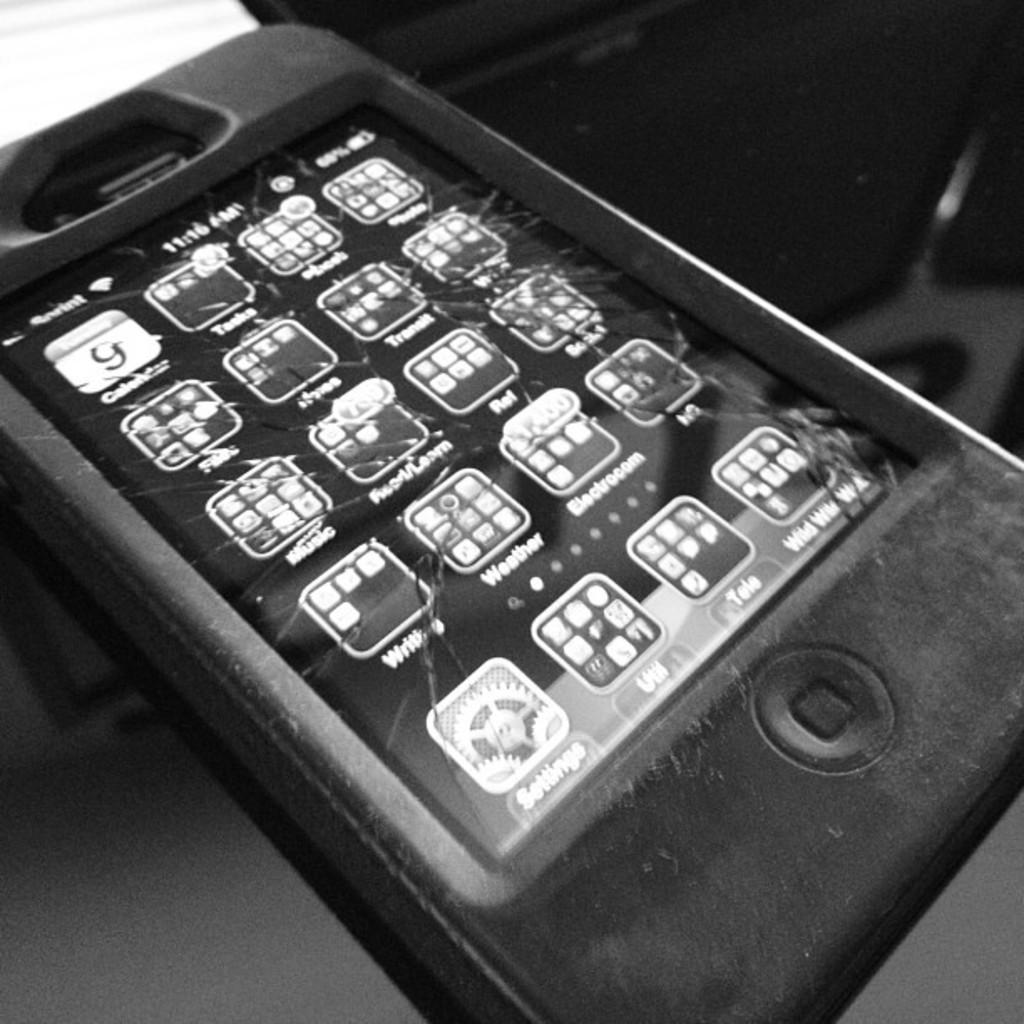<image>
Create a compact narrative representing the image presented. An iPhone in a thick case has a cracked screen and the settings icon is on the bottom left. 